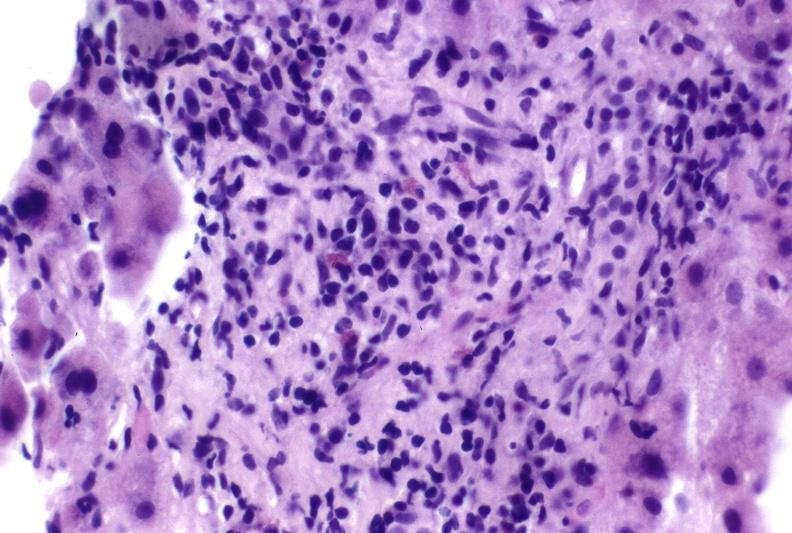what does this image show?
Answer the question using a single word or phrase. Autoimmune hepatitis 